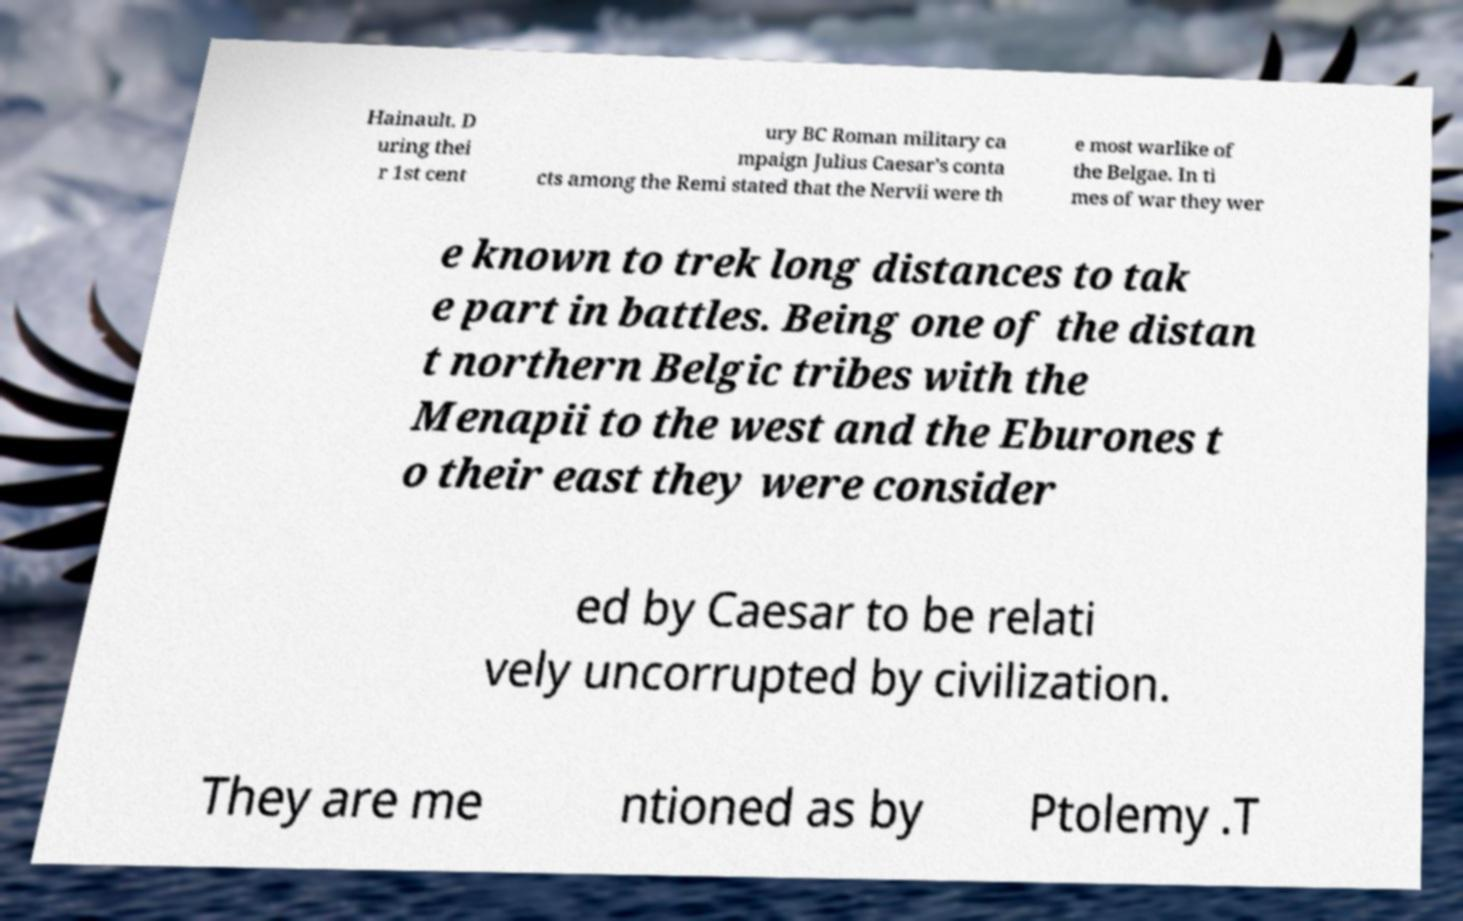I need the written content from this picture converted into text. Can you do that? Hainault. D uring thei r 1st cent ury BC Roman military ca mpaign Julius Caesar's conta cts among the Remi stated that the Nervii were th e most warlike of the Belgae. In ti mes of war they wer e known to trek long distances to tak e part in battles. Being one of the distan t northern Belgic tribes with the Menapii to the west and the Eburones t o their east they were consider ed by Caesar to be relati vely uncorrupted by civilization. They are me ntioned as by Ptolemy .T 